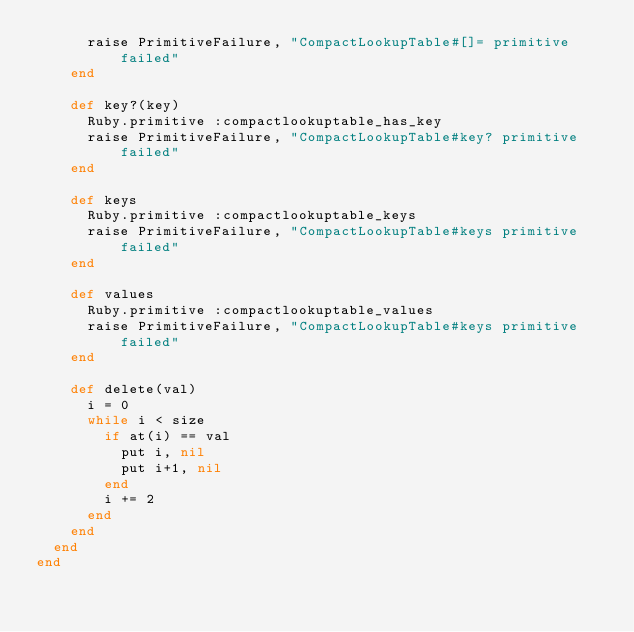<code> <loc_0><loc_0><loc_500><loc_500><_Ruby_>      raise PrimitiveFailure, "CompactLookupTable#[]= primitive failed"
    end

    def key?(key)
      Ruby.primitive :compactlookuptable_has_key
      raise PrimitiveFailure, "CompactLookupTable#key? primitive failed"
    end

    def keys
      Ruby.primitive :compactlookuptable_keys
      raise PrimitiveFailure, "CompactLookupTable#keys primitive failed"
    end

    def values
      Ruby.primitive :compactlookuptable_values
      raise PrimitiveFailure, "CompactLookupTable#keys primitive failed"
    end

    def delete(val)
      i = 0
      while i < size
        if at(i) == val
          put i, nil
          put i+1, nil
        end
        i += 2
      end
    end
  end
end
</code> 